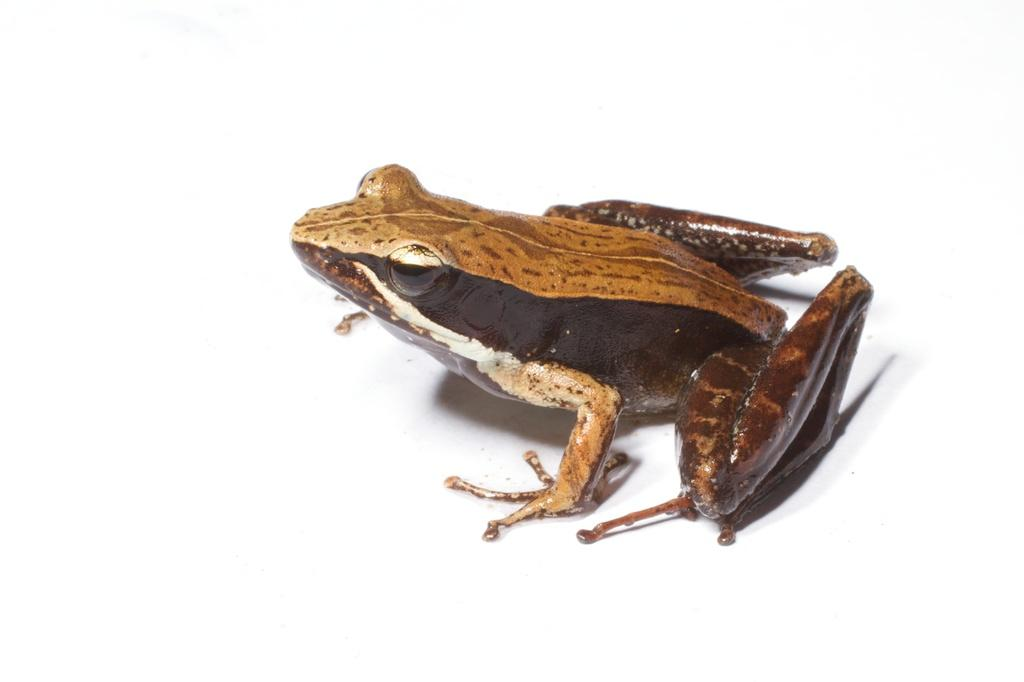What type of animal is present in the image? There is a frog in the image. What type of lunch is being served by the servant in the image? There is no servant or lunch present in the image; it only features a frog. 